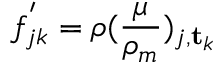<formula> <loc_0><loc_0><loc_500><loc_500>f _ { j k } ^ { ^ { \prime } } = \rho ( \frac { \mu } { \rho _ { m } } ) _ { j , t _ { k } }</formula> 